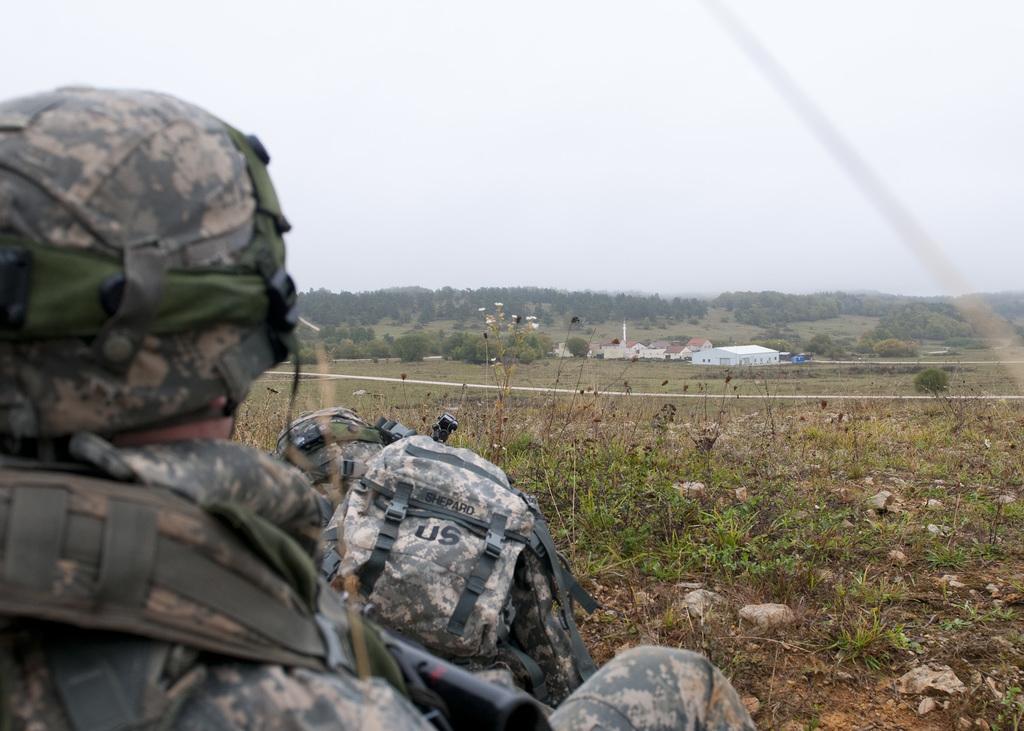Describe this image in one or two sentences. Left side of the image there is a person wearing a uniform and a helmet. Before him there are few bags on the land having some grass, plants and few rocks on it. Middle of the image there are few houses. Background there are few trees. Top of the image there is sky. 